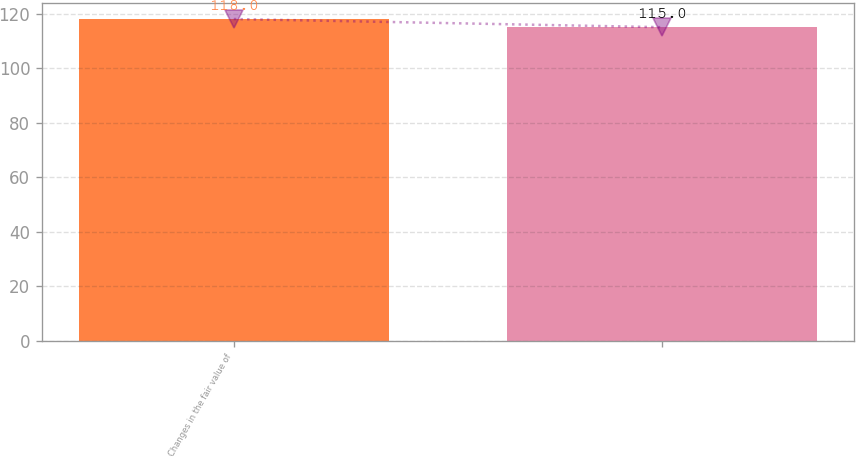Convert chart. <chart><loc_0><loc_0><loc_500><loc_500><bar_chart><fcel>Changes in the fair value of<fcel>Unnamed: 1<nl><fcel>118<fcel>115<nl></chart> 